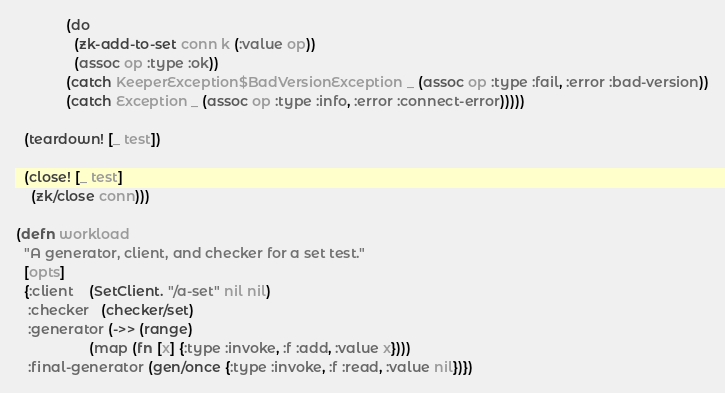<code> <loc_0><loc_0><loc_500><loc_500><_Clojure_>             (do
               (zk-add-to-set conn k (:value op))
               (assoc op :type :ok))
             (catch KeeperException$BadVersionException _ (assoc op :type :fail, :error :bad-version))
             (catch Exception _ (assoc op :type :info, :error :connect-error)))))

  (teardown! [_ test])

  (close! [_ test]
    (zk/close conn)))

(defn workload
  "A generator, client, and checker for a set test."
  [opts]
  {:client    (SetClient. "/a-set" nil nil)
   :checker   (checker/set)
   :generator (->> (range)
                   (map (fn [x] {:type :invoke, :f :add, :value x})))
   :final-generator (gen/once {:type :invoke, :f :read, :value nil})})
</code> 